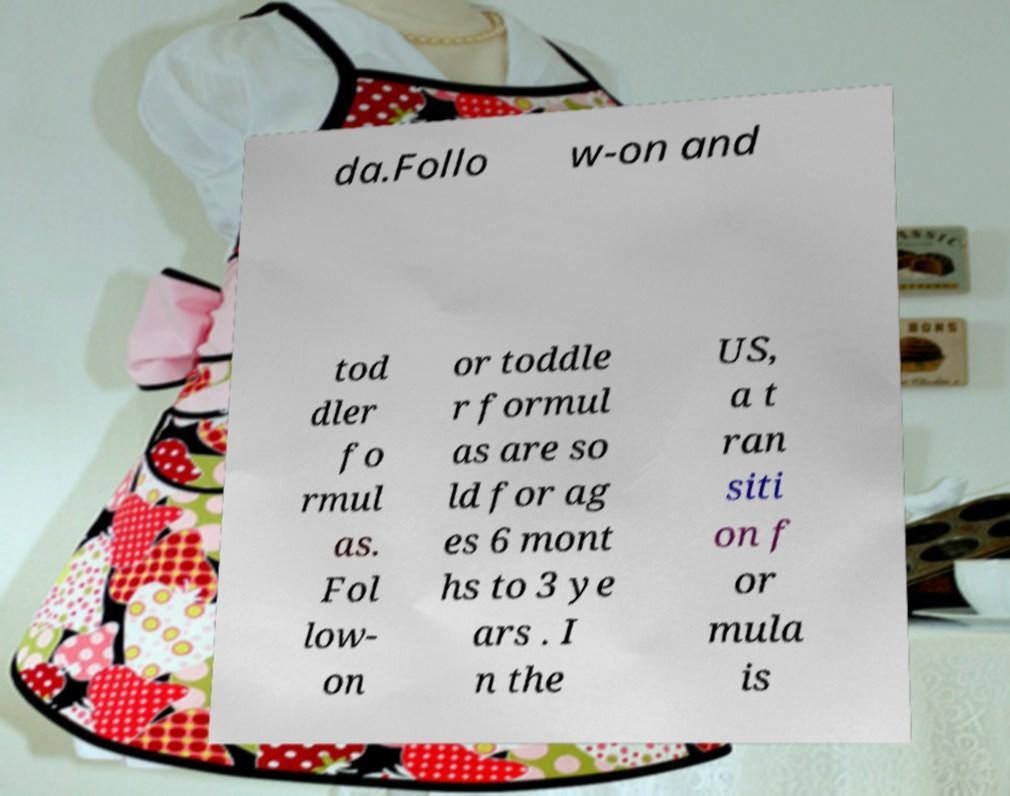For documentation purposes, I need the text within this image transcribed. Could you provide that? da.Follo w-on and tod dler fo rmul as. Fol low- on or toddle r formul as are so ld for ag es 6 mont hs to 3 ye ars . I n the US, a t ran siti on f or mula is 